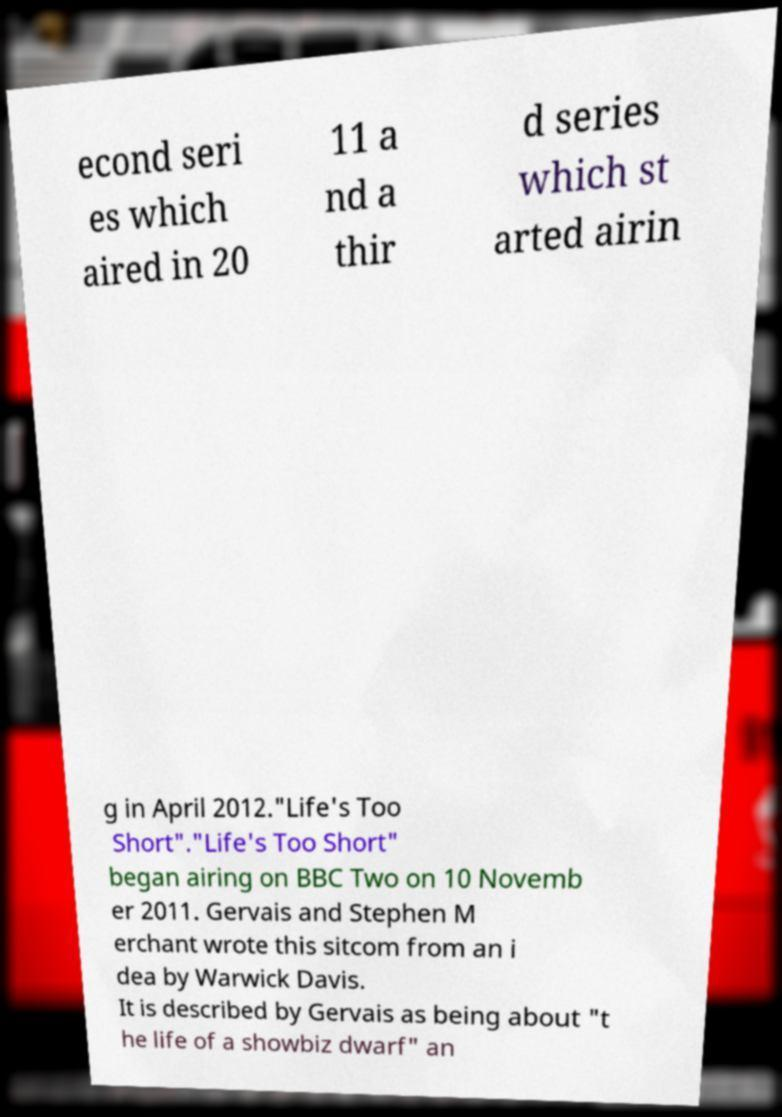I need the written content from this picture converted into text. Can you do that? econd seri es which aired in 20 11 a nd a thir d series which st arted airin g in April 2012."Life's Too Short"."Life's Too Short" began airing on BBC Two on 10 Novemb er 2011. Gervais and Stephen M erchant wrote this sitcom from an i dea by Warwick Davis. It is described by Gervais as being about "t he life of a showbiz dwarf" an 